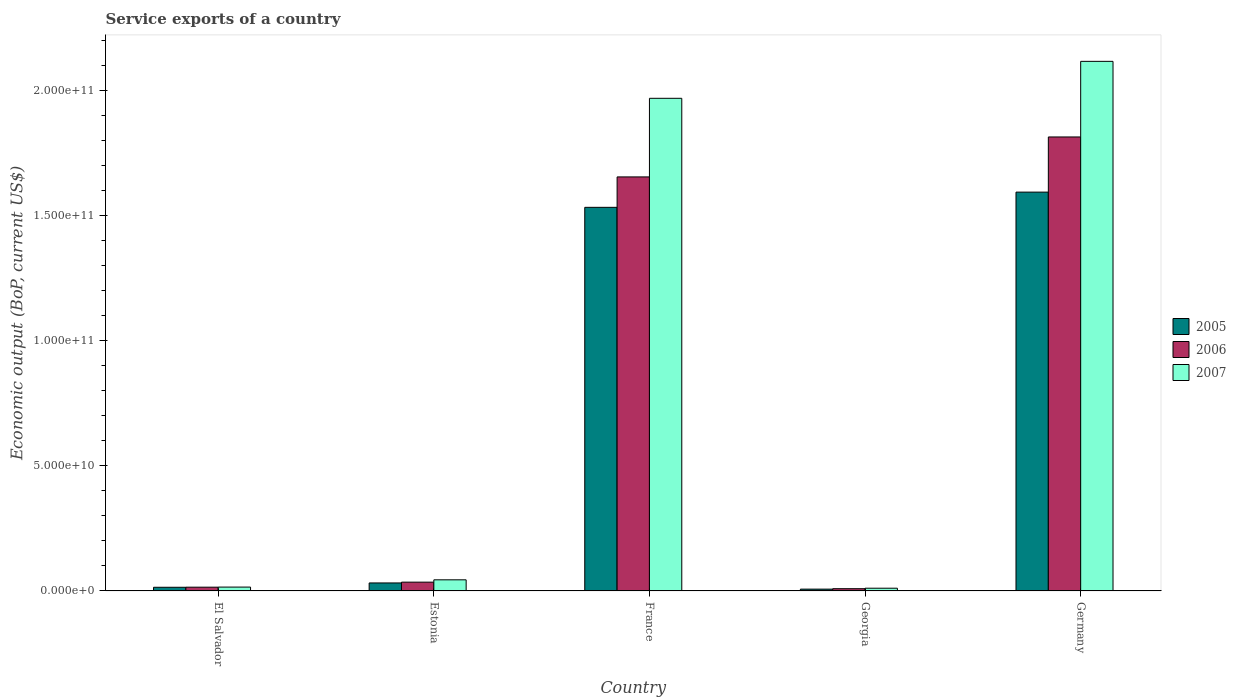Are the number of bars per tick equal to the number of legend labels?
Offer a terse response. Yes. What is the label of the 1st group of bars from the left?
Give a very brief answer. El Salvador. In how many cases, is the number of bars for a given country not equal to the number of legend labels?
Make the answer very short. 0. What is the service exports in 2007 in Germany?
Offer a terse response. 2.12e+11. Across all countries, what is the maximum service exports in 2007?
Your answer should be compact. 2.12e+11. Across all countries, what is the minimum service exports in 2006?
Your answer should be compact. 9.13e+08. In which country was the service exports in 2006 maximum?
Give a very brief answer. Germany. In which country was the service exports in 2005 minimum?
Give a very brief answer. Georgia. What is the total service exports in 2005 in the graph?
Give a very brief answer. 3.18e+11. What is the difference between the service exports in 2006 in France and that in Germany?
Provide a short and direct response. -1.60e+1. What is the difference between the service exports in 2007 in Georgia and the service exports in 2006 in Estonia?
Ensure brevity in your answer.  -2.42e+09. What is the average service exports in 2006 per country?
Give a very brief answer. 7.06e+1. What is the difference between the service exports of/in 2006 and service exports of/in 2007 in France?
Your answer should be very brief. -3.14e+1. What is the ratio of the service exports in 2007 in El Salvador to that in Germany?
Provide a succinct answer. 0.01. Is the difference between the service exports in 2006 in El Salvador and Georgia greater than the difference between the service exports in 2007 in El Salvador and Georgia?
Your answer should be very brief. Yes. What is the difference between the highest and the second highest service exports in 2006?
Offer a very short reply. 1.60e+1. What is the difference between the highest and the lowest service exports in 2007?
Your answer should be very brief. 2.10e+11. In how many countries, is the service exports in 2006 greater than the average service exports in 2006 taken over all countries?
Make the answer very short. 2. Is the sum of the service exports in 2006 in Estonia and Georgia greater than the maximum service exports in 2005 across all countries?
Provide a succinct answer. No. What does the 1st bar from the left in France represents?
Make the answer very short. 2005. Are all the bars in the graph horizontal?
Provide a short and direct response. No. What is the difference between two consecutive major ticks on the Y-axis?
Your response must be concise. 5.00e+1. Are the values on the major ticks of Y-axis written in scientific E-notation?
Make the answer very short. Yes. Does the graph contain any zero values?
Provide a succinct answer. No. Does the graph contain grids?
Offer a very short reply. No. What is the title of the graph?
Give a very brief answer. Service exports of a country. Does "2015" appear as one of the legend labels in the graph?
Your answer should be very brief. No. What is the label or title of the Y-axis?
Provide a short and direct response. Economic output (BoP, current US$). What is the Economic output (BoP, current US$) in 2005 in El Salvador?
Offer a terse response. 1.48e+09. What is the Economic output (BoP, current US$) of 2006 in El Salvador?
Offer a very short reply. 1.52e+09. What is the Economic output (BoP, current US$) of 2007 in El Salvador?
Your response must be concise. 1.56e+09. What is the Economic output (BoP, current US$) in 2005 in Estonia?
Offer a terse response. 3.21e+09. What is the Economic output (BoP, current US$) of 2006 in Estonia?
Offer a very short reply. 3.52e+09. What is the Economic output (BoP, current US$) in 2007 in Estonia?
Your answer should be very brief. 4.46e+09. What is the Economic output (BoP, current US$) in 2005 in France?
Give a very brief answer. 1.53e+11. What is the Economic output (BoP, current US$) of 2006 in France?
Provide a succinct answer. 1.65e+11. What is the Economic output (BoP, current US$) in 2007 in France?
Your answer should be compact. 1.97e+11. What is the Economic output (BoP, current US$) in 2005 in Georgia?
Your response must be concise. 7.38e+08. What is the Economic output (BoP, current US$) in 2006 in Georgia?
Make the answer very short. 9.13e+08. What is the Economic output (BoP, current US$) of 2007 in Georgia?
Your answer should be very brief. 1.11e+09. What is the Economic output (BoP, current US$) in 2005 in Germany?
Make the answer very short. 1.59e+11. What is the Economic output (BoP, current US$) of 2006 in Germany?
Provide a short and direct response. 1.81e+11. What is the Economic output (BoP, current US$) of 2007 in Germany?
Your response must be concise. 2.12e+11. Across all countries, what is the maximum Economic output (BoP, current US$) of 2005?
Keep it short and to the point. 1.59e+11. Across all countries, what is the maximum Economic output (BoP, current US$) of 2006?
Give a very brief answer. 1.81e+11. Across all countries, what is the maximum Economic output (BoP, current US$) in 2007?
Keep it short and to the point. 2.12e+11. Across all countries, what is the minimum Economic output (BoP, current US$) of 2005?
Provide a succinct answer. 7.38e+08. Across all countries, what is the minimum Economic output (BoP, current US$) of 2006?
Provide a short and direct response. 9.13e+08. Across all countries, what is the minimum Economic output (BoP, current US$) in 2007?
Give a very brief answer. 1.11e+09. What is the total Economic output (BoP, current US$) in 2005 in the graph?
Offer a very short reply. 3.18e+11. What is the total Economic output (BoP, current US$) in 2006 in the graph?
Keep it short and to the point. 3.53e+11. What is the total Economic output (BoP, current US$) of 2007 in the graph?
Offer a very short reply. 4.16e+11. What is the difference between the Economic output (BoP, current US$) in 2005 in El Salvador and that in Estonia?
Provide a short and direct response. -1.73e+09. What is the difference between the Economic output (BoP, current US$) in 2006 in El Salvador and that in Estonia?
Keep it short and to the point. -2.01e+09. What is the difference between the Economic output (BoP, current US$) in 2007 in El Salvador and that in Estonia?
Offer a terse response. -2.90e+09. What is the difference between the Economic output (BoP, current US$) in 2005 in El Salvador and that in France?
Ensure brevity in your answer.  -1.52e+11. What is the difference between the Economic output (BoP, current US$) of 2006 in El Salvador and that in France?
Your response must be concise. -1.64e+11. What is the difference between the Economic output (BoP, current US$) in 2007 in El Salvador and that in France?
Make the answer very short. -1.95e+11. What is the difference between the Economic output (BoP, current US$) of 2005 in El Salvador and that in Georgia?
Your answer should be compact. 7.40e+08. What is the difference between the Economic output (BoP, current US$) in 2006 in El Salvador and that in Georgia?
Your answer should be compact. 6.02e+08. What is the difference between the Economic output (BoP, current US$) of 2007 in El Salvador and that in Georgia?
Your answer should be compact. 4.49e+08. What is the difference between the Economic output (BoP, current US$) in 2005 in El Salvador and that in Germany?
Keep it short and to the point. -1.58e+11. What is the difference between the Economic output (BoP, current US$) of 2006 in El Salvador and that in Germany?
Provide a succinct answer. -1.80e+11. What is the difference between the Economic output (BoP, current US$) of 2007 in El Salvador and that in Germany?
Make the answer very short. -2.10e+11. What is the difference between the Economic output (BoP, current US$) in 2005 in Estonia and that in France?
Offer a very short reply. -1.50e+11. What is the difference between the Economic output (BoP, current US$) in 2006 in Estonia and that in France?
Keep it short and to the point. -1.62e+11. What is the difference between the Economic output (BoP, current US$) of 2007 in Estonia and that in France?
Provide a succinct answer. -1.92e+11. What is the difference between the Economic output (BoP, current US$) in 2005 in Estonia and that in Georgia?
Your answer should be compact. 2.47e+09. What is the difference between the Economic output (BoP, current US$) of 2006 in Estonia and that in Georgia?
Your answer should be very brief. 2.61e+09. What is the difference between the Economic output (BoP, current US$) in 2007 in Estonia and that in Georgia?
Provide a succinct answer. 3.35e+09. What is the difference between the Economic output (BoP, current US$) in 2005 in Estonia and that in Germany?
Offer a terse response. -1.56e+11. What is the difference between the Economic output (BoP, current US$) in 2006 in Estonia and that in Germany?
Offer a terse response. -1.78e+11. What is the difference between the Economic output (BoP, current US$) of 2007 in Estonia and that in Germany?
Your answer should be compact. -2.07e+11. What is the difference between the Economic output (BoP, current US$) of 2005 in France and that in Georgia?
Give a very brief answer. 1.53e+11. What is the difference between the Economic output (BoP, current US$) of 2006 in France and that in Georgia?
Your answer should be very brief. 1.65e+11. What is the difference between the Economic output (BoP, current US$) in 2007 in France and that in Georgia?
Give a very brief answer. 1.96e+11. What is the difference between the Economic output (BoP, current US$) of 2005 in France and that in Germany?
Provide a succinct answer. -6.08e+09. What is the difference between the Economic output (BoP, current US$) in 2006 in France and that in Germany?
Make the answer very short. -1.60e+1. What is the difference between the Economic output (BoP, current US$) of 2007 in France and that in Germany?
Keep it short and to the point. -1.48e+1. What is the difference between the Economic output (BoP, current US$) of 2005 in Georgia and that in Germany?
Your answer should be very brief. -1.59e+11. What is the difference between the Economic output (BoP, current US$) of 2006 in Georgia and that in Germany?
Offer a terse response. -1.80e+11. What is the difference between the Economic output (BoP, current US$) of 2007 in Georgia and that in Germany?
Keep it short and to the point. -2.10e+11. What is the difference between the Economic output (BoP, current US$) of 2005 in El Salvador and the Economic output (BoP, current US$) of 2006 in Estonia?
Your answer should be compact. -2.05e+09. What is the difference between the Economic output (BoP, current US$) in 2005 in El Salvador and the Economic output (BoP, current US$) in 2007 in Estonia?
Your answer should be very brief. -2.98e+09. What is the difference between the Economic output (BoP, current US$) of 2006 in El Salvador and the Economic output (BoP, current US$) of 2007 in Estonia?
Make the answer very short. -2.94e+09. What is the difference between the Economic output (BoP, current US$) of 2005 in El Salvador and the Economic output (BoP, current US$) of 2006 in France?
Your answer should be very brief. -1.64e+11. What is the difference between the Economic output (BoP, current US$) in 2005 in El Salvador and the Economic output (BoP, current US$) in 2007 in France?
Make the answer very short. -1.95e+11. What is the difference between the Economic output (BoP, current US$) of 2006 in El Salvador and the Economic output (BoP, current US$) of 2007 in France?
Offer a very short reply. -1.95e+11. What is the difference between the Economic output (BoP, current US$) in 2005 in El Salvador and the Economic output (BoP, current US$) in 2006 in Georgia?
Ensure brevity in your answer.  5.65e+08. What is the difference between the Economic output (BoP, current US$) of 2005 in El Salvador and the Economic output (BoP, current US$) of 2007 in Georgia?
Give a very brief answer. 3.71e+08. What is the difference between the Economic output (BoP, current US$) of 2006 in El Salvador and the Economic output (BoP, current US$) of 2007 in Georgia?
Your response must be concise. 4.09e+08. What is the difference between the Economic output (BoP, current US$) in 2005 in El Salvador and the Economic output (BoP, current US$) in 2006 in Germany?
Give a very brief answer. -1.80e+11. What is the difference between the Economic output (BoP, current US$) in 2005 in El Salvador and the Economic output (BoP, current US$) in 2007 in Germany?
Make the answer very short. -2.10e+11. What is the difference between the Economic output (BoP, current US$) in 2006 in El Salvador and the Economic output (BoP, current US$) in 2007 in Germany?
Your response must be concise. -2.10e+11. What is the difference between the Economic output (BoP, current US$) in 2005 in Estonia and the Economic output (BoP, current US$) in 2006 in France?
Keep it short and to the point. -1.62e+11. What is the difference between the Economic output (BoP, current US$) of 2005 in Estonia and the Economic output (BoP, current US$) of 2007 in France?
Your answer should be compact. -1.94e+11. What is the difference between the Economic output (BoP, current US$) of 2006 in Estonia and the Economic output (BoP, current US$) of 2007 in France?
Offer a very short reply. -1.93e+11. What is the difference between the Economic output (BoP, current US$) in 2005 in Estonia and the Economic output (BoP, current US$) in 2006 in Georgia?
Your response must be concise. 2.30e+09. What is the difference between the Economic output (BoP, current US$) in 2005 in Estonia and the Economic output (BoP, current US$) in 2007 in Georgia?
Make the answer very short. 2.10e+09. What is the difference between the Economic output (BoP, current US$) in 2006 in Estonia and the Economic output (BoP, current US$) in 2007 in Georgia?
Offer a very short reply. 2.42e+09. What is the difference between the Economic output (BoP, current US$) in 2005 in Estonia and the Economic output (BoP, current US$) in 2006 in Germany?
Make the answer very short. -1.78e+11. What is the difference between the Economic output (BoP, current US$) of 2005 in Estonia and the Economic output (BoP, current US$) of 2007 in Germany?
Keep it short and to the point. -2.08e+11. What is the difference between the Economic output (BoP, current US$) of 2006 in Estonia and the Economic output (BoP, current US$) of 2007 in Germany?
Give a very brief answer. -2.08e+11. What is the difference between the Economic output (BoP, current US$) in 2005 in France and the Economic output (BoP, current US$) in 2006 in Georgia?
Make the answer very short. 1.52e+11. What is the difference between the Economic output (BoP, current US$) of 2005 in France and the Economic output (BoP, current US$) of 2007 in Georgia?
Provide a short and direct response. 1.52e+11. What is the difference between the Economic output (BoP, current US$) of 2006 in France and the Economic output (BoP, current US$) of 2007 in Georgia?
Ensure brevity in your answer.  1.64e+11. What is the difference between the Economic output (BoP, current US$) in 2005 in France and the Economic output (BoP, current US$) in 2006 in Germany?
Provide a succinct answer. -2.81e+1. What is the difference between the Economic output (BoP, current US$) of 2005 in France and the Economic output (BoP, current US$) of 2007 in Germany?
Keep it short and to the point. -5.83e+1. What is the difference between the Economic output (BoP, current US$) of 2006 in France and the Economic output (BoP, current US$) of 2007 in Germany?
Offer a terse response. -4.62e+1. What is the difference between the Economic output (BoP, current US$) in 2005 in Georgia and the Economic output (BoP, current US$) in 2006 in Germany?
Keep it short and to the point. -1.81e+11. What is the difference between the Economic output (BoP, current US$) in 2005 in Georgia and the Economic output (BoP, current US$) in 2007 in Germany?
Provide a succinct answer. -2.11e+11. What is the difference between the Economic output (BoP, current US$) in 2006 in Georgia and the Economic output (BoP, current US$) in 2007 in Germany?
Keep it short and to the point. -2.11e+11. What is the average Economic output (BoP, current US$) in 2005 per country?
Keep it short and to the point. 6.36e+1. What is the average Economic output (BoP, current US$) of 2006 per country?
Your answer should be very brief. 7.06e+1. What is the average Economic output (BoP, current US$) of 2007 per country?
Offer a terse response. 8.31e+1. What is the difference between the Economic output (BoP, current US$) of 2005 and Economic output (BoP, current US$) of 2006 in El Salvador?
Ensure brevity in your answer.  -3.79e+07. What is the difference between the Economic output (BoP, current US$) in 2005 and Economic output (BoP, current US$) in 2007 in El Salvador?
Give a very brief answer. -7.76e+07. What is the difference between the Economic output (BoP, current US$) of 2006 and Economic output (BoP, current US$) of 2007 in El Salvador?
Give a very brief answer. -3.97e+07. What is the difference between the Economic output (BoP, current US$) of 2005 and Economic output (BoP, current US$) of 2006 in Estonia?
Offer a very short reply. -3.15e+08. What is the difference between the Economic output (BoP, current US$) in 2005 and Economic output (BoP, current US$) in 2007 in Estonia?
Ensure brevity in your answer.  -1.25e+09. What is the difference between the Economic output (BoP, current US$) of 2006 and Economic output (BoP, current US$) of 2007 in Estonia?
Ensure brevity in your answer.  -9.32e+08. What is the difference between the Economic output (BoP, current US$) of 2005 and Economic output (BoP, current US$) of 2006 in France?
Offer a very short reply. -1.22e+1. What is the difference between the Economic output (BoP, current US$) of 2005 and Economic output (BoP, current US$) of 2007 in France?
Keep it short and to the point. -4.36e+1. What is the difference between the Economic output (BoP, current US$) in 2006 and Economic output (BoP, current US$) in 2007 in France?
Your answer should be very brief. -3.14e+1. What is the difference between the Economic output (BoP, current US$) of 2005 and Economic output (BoP, current US$) of 2006 in Georgia?
Give a very brief answer. -1.76e+08. What is the difference between the Economic output (BoP, current US$) in 2005 and Economic output (BoP, current US$) in 2007 in Georgia?
Offer a very short reply. -3.69e+08. What is the difference between the Economic output (BoP, current US$) in 2006 and Economic output (BoP, current US$) in 2007 in Georgia?
Provide a succinct answer. -1.94e+08. What is the difference between the Economic output (BoP, current US$) of 2005 and Economic output (BoP, current US$) of 2006 in Germany?
Ensure brevity in your answer.  -2.20e+1. What is the difference between the Economic output (BoP, current US$) in 2005 and Economic output (BoP, current US$) in 2007 in Germany?
Your response must be concise. -5.22e+1. What is the difference between the Economic output (BoP, current US$) of 2006 and Economic output (BoP, current US$) of 2007 in Germany?
Offer a very short reply. -3.02e+1. What is the ratio of the Economic output (BoP, current US$) of 2005 in El Salvador to that in Estonia?
Provide a succinct answer. 0.46. What is the ratio of the Economic output (BoP, current US$) in 2006 in El Salvador to that in Estonia?
Your response must be concise. 0.43. What is the ratio of the Economic output (BoP, current US$) in 2007 in El Salvador to that in Estonia?
Offer a very short reply. 0.35. What is the ratio of the Economic output (BoP, current US$) of 2005 in El Salvador to that in France?
Provide a succinct answer. 0.01. What is the ratio of the Economic output (BoP, current US$) of 2006 in El Salvador to that in France?
Provide a short and direct response. 0.01. What is the ratio of the Economic output (BoP, current US$) of 2007 in El Salvador to that in France?
Provide a short and direct response. 0.01. What is the ratio of the Economic output (BoP, current US$) in 2005 in El Salvador to that in Georgia?
Your response must be concise. 2. What is the ratio of the Economic output (BoP, current US$) of 2006 in El Salvador to that in Georgia?
Your answer should be very brief. 1.66. What is the ratio of the Economic output (BoP, current US$) of 2007 in El Salvador to that in Georgia?
Offer a terse response. 1.41. What is the ratio of the Economic output (BoP, current US$) in 2005 in El Salvador to that in Germany?
Offer a very short reply. 0.01. What is the ratio of the Economic output (BoP, current US$) of 2006 in El Salvador to that in Germany?
Ensure brevity in your answer.  0.01. What is the ratio of the Economic output (BoP, current US$) of 2007 in El Salvador to that in Germany?
Your response must be concise. 0.01. What is the ratio of the Economic output (BoP, current US$) of 2005 in Estonia to that in France?
Your answer should be compact. 0.02. What is the ratio of the Economic output (BoP, current US$) of 2006 in Estonia to that in France?
Your answer should be very brief. 0.02. What is the ratio of the Economic output (BoP, current US$) of 2007 in Estonia to that in France?
Give a very brief answer. 0.02. What is the ratio of the Economic output (BoP, current US$) in 2005 in Estonia to that in Georgia?
Keep it short and to the point. 4.35. What is the ratio of the Economic output (BoP, current US$) of 2006 in Estonia to that in Georgia?
Provide a short and direct response. 3.86. What is the ratio of the Economic output (BoP, current US$) in 2007 in Estonia to that in Georgia?
Provide a succinct answer. 4.03. What is the ratio of the Economic output (BoP, current US$) of 2005 in Estonia to that in Germany?
Provide a short and direct response. 0.02. What is the ratio of the Economic output (BoP, current US$) of 2006 in Estonia to that in Germany?
Make the answer very short. 0.02. What is the ratio of the Economic output (BoP, current US$) of 2007 in Estonia to that in Germany?
Your answer should be compact. 0.02. What is the ratio of the Economic output (BoP, current US$) in 2005 in France to that in Georgia?
Keep it short and to the point. 207.71. What is the ratio of the Economic output (BoP, current US$) in 2006 in France to that in Georgia?
Your answer should be compact. 181.09. What is the ratio of the Economic output (BoP, current US$) in 2007 in France to that in Georgia?
Ensure brevity in your answer.  177.79. What is the ratio of the Economic output (BoP, current US$) of 2005 in France to that in Germany?
Ensure brevity in your answer.  0.96. What is the ratio of the Economic output (BoP, current US$) in 2006 in France to that in Germany?
Offer a very short reply. 0.91. What is the ratio of the Economic output (BoP, current US$) of 2007 in France to that in Germany?
Offer a terse response. 0.93. What is the ratio of the Economic output (BoP, current US$) of 2005 in Georgia to that in Germany?
Offer a terse response. 0. What is the ratio of the Economic output (BoP, current US$) in 2006 in Georgia to that in Germany?
Your answer should be compact. 0.01. What is the ratio of the Economic output (BoP, current US$) in 2007 in Georgia to that in Germany?
Offer a very short reply. 0.01. What is the difference between the highest and the second highest Economic output (BoP, current US$) in 2005?
Provide a succinct answer. 6.08e+09. What is the difference between the highest and the second highest Economic output (BoP, current US$) of 2006?
Give a very brief answer. 1.60e+1. What is the difference between the highest and the second highest Economic output (BoP, current US$) of 2007?
Give a very brief answer. 1.48e+1. What is the difference between the highest and the lowest Economic output (BoP, current US$) in 2005?
Your answer should be very brief. 1.59e+11. What is the difference between the highest and the lowest Economic output (BoP, current US$) of 2006?
Your answer should be very brief. 1.80e+11. What is the difference between the highest and the lowest Economic output (BoP, current US$) in 2007?
Give a very brief answer. 2.10e+11. 